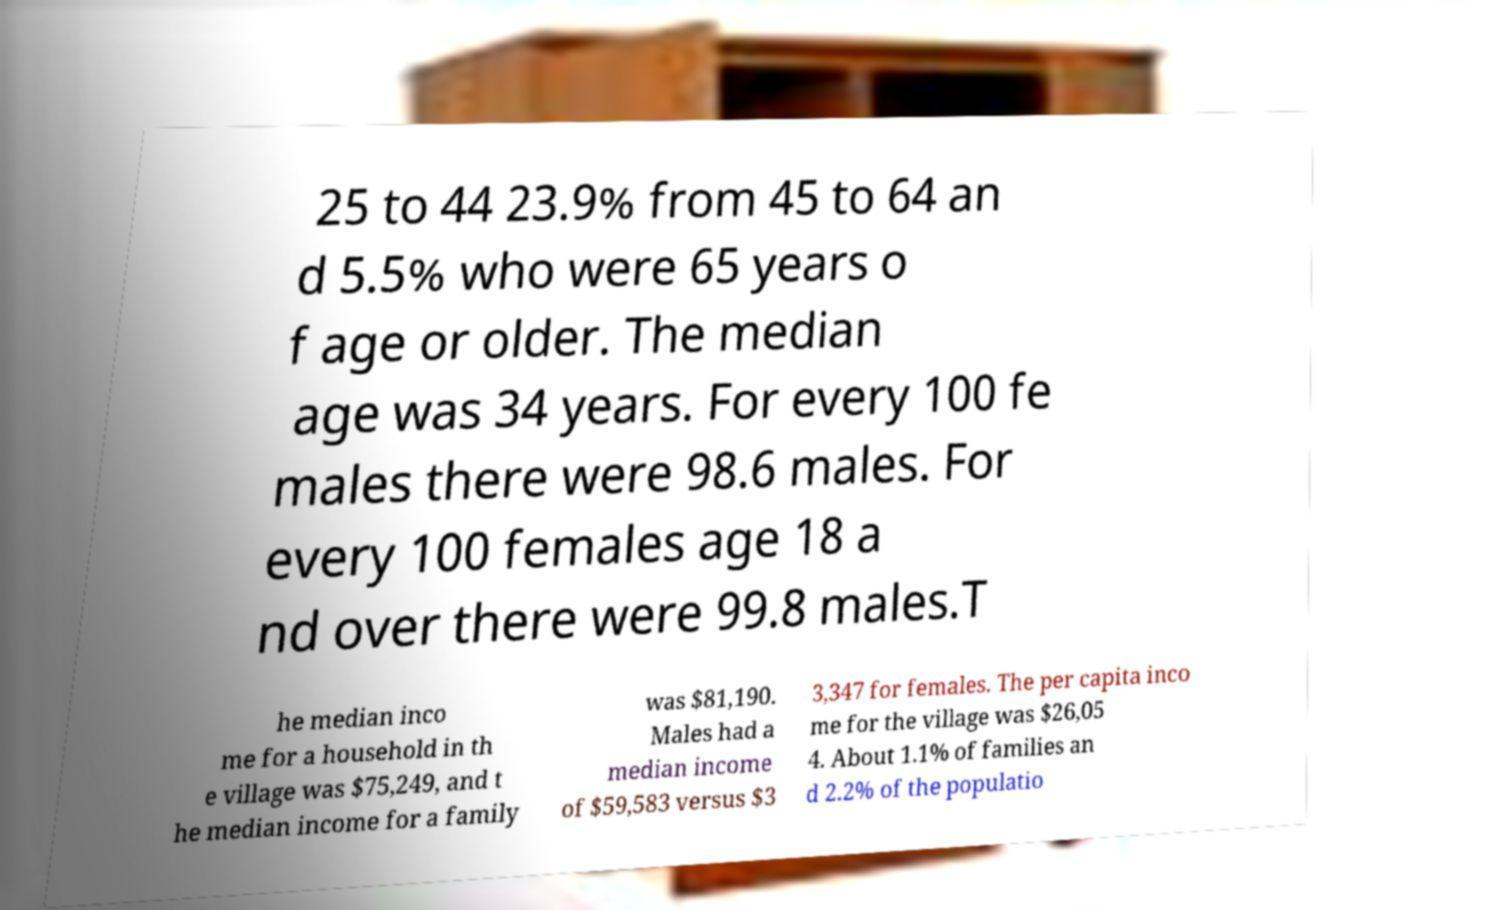There's text embedded in this image that I need extracted. Can you transcribe it verbatim? 25 to 44 23.9% from 45 to 64 an d 5.5% who were 65 years o f age or older. The median age was 34 years. For every 100 fe males there were 98.6 males. For every 100 females age 18 a nd over there were 99.8 males.T he median inco me for a household in th e village was $75,249, and t he median income for a family was $81,190. Males had a median income of $59,583 versus $3 3,347 for females. The per capita inco me for the village was $26,05 4. About 1.1% of families an d 2.2% of the populatio 